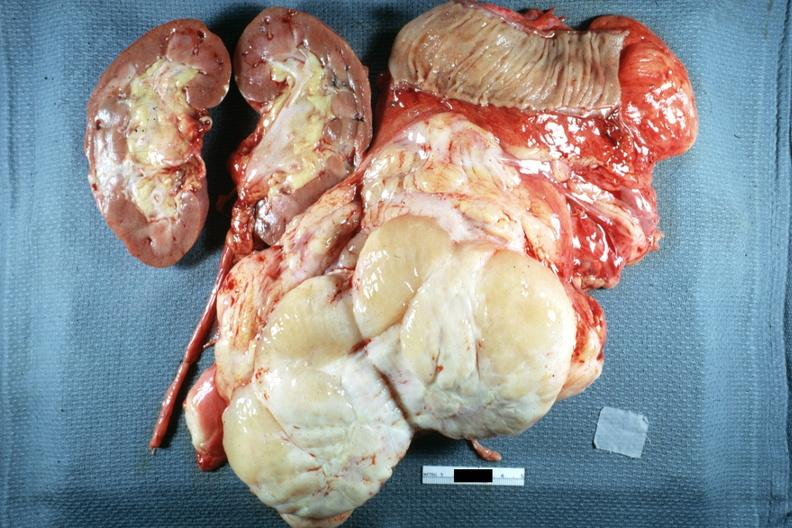s peritoneum present?
Answer the question using a single word or phrase. Yes 